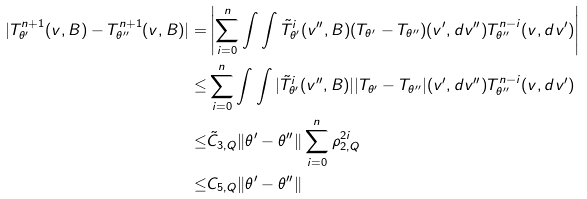Convert formula to latex. <formula><loc_0><loc_0><loc_500><loc_500>| T _ { \theta ^ { \prime } } ^ { n + 1 } ( v , B ) - T _ { \theta ^ { \prime \prime } } ^ { n + 1 } ( v , B ) | = & \left | \sum _ { i = 0 } ^ { n } \int \int \tilde { T } _ { \theta ^ { \prime } } ^ { i } ( v ^ { \prime \prime } , B ) ( T _ { \theta ^ { \prime } } - T _ { \theta ^ { \prime \prime } } ) ( v ^ { \prime } , d v ^ { \prime \prime } ) T _ { \theta ^ { \prime \prime } } ^ { n - i } ( v , d v ^ { \prime } ) \right | \\ \leq & \sum _ { i = 0 } ^ { n } \int \int | \tilde { T } _ { \theta ^ { \prime } } ^ { i } ( v ^ { \prime \prime } , B ) | | T _ { \theta ^ { \prime } } - T _ { \theta ^ { \prime \prime } } | ( v ^ { \prime } , d v ^ { \prime \prime } ) T _ { \theta ^ { \prime \prime } } ^ { n - i } ( v , d v ^ { \prime } ) \\ \leq & \tilde { C } _ { 3 , Q } \| \theta ^ { \prime } - \theta ^ { \prime \prime } \| \sum _ { i = 0 } ^ { n } \rho _ { 2 , Q } ^ { 2 i } \\ \leq & C _ { 5 , Q } \| \theta ^ { \prime } - \theta ^ { \prime \prime } \|</formula> 